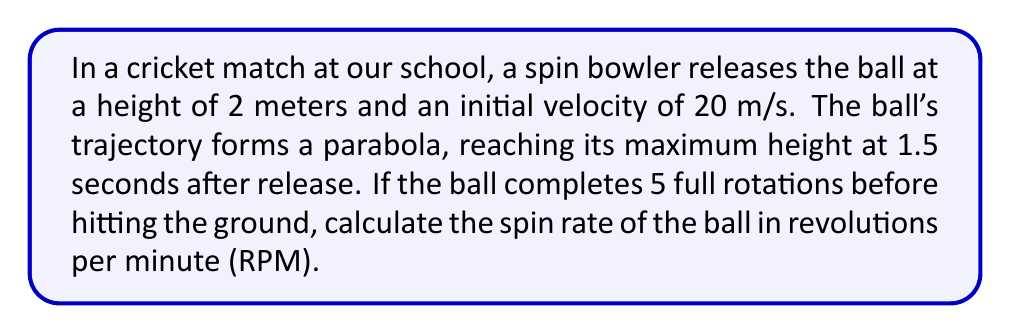Show me your answer to this math problem. Let's approach this step-by-step:

1) First, we need to find the time it takes for the ball to hit the ground. We can use the equation of motion:

   $y = -\frac{1}{2}gt^2 + v_0\sin\theta \cdot t + h_0$

   Where $g = 9.8$ m/s², $h_0 = 2$ m (initial height), and $t$ is the time to reach maximum height (1.5 s).

2) At maximum height, vertical velocity is zero. We can use this to find $v_0\sin\theta$:

   $0 = -gt + v_0\sin\theta$
   $v_0\sin\theta = g \cdot 1.5 = 9.8 \cdot 1.5 = 14.7$ m/s

3) Now we can substitute this back into our original equation:

   $y = -4.9t^2 + 14.7t + 2$

4) To find when the ball hits the ground, we set $y = 0$ and solve for $t$:

   $0 = -4.9t^2 + 14.7t + 2$

   Using the quadratic formula, we get $t \approx 3.27$ seconds.

5) Now we know the ball is in the air for 3.27 seconds and completes 5 rotations in this time.

6) To convert this to RPM:

   $\text{RPM} = \frac{5 \text{ rotations}}{3.27 \text{ seconds}} \cdot \frac{60 \text{ seconds}}{1 \text{ minute}} \approx 91.74$

Therefore, the spin rate of the ball is approximately 92 RPM.
Answer: 92 RPM 